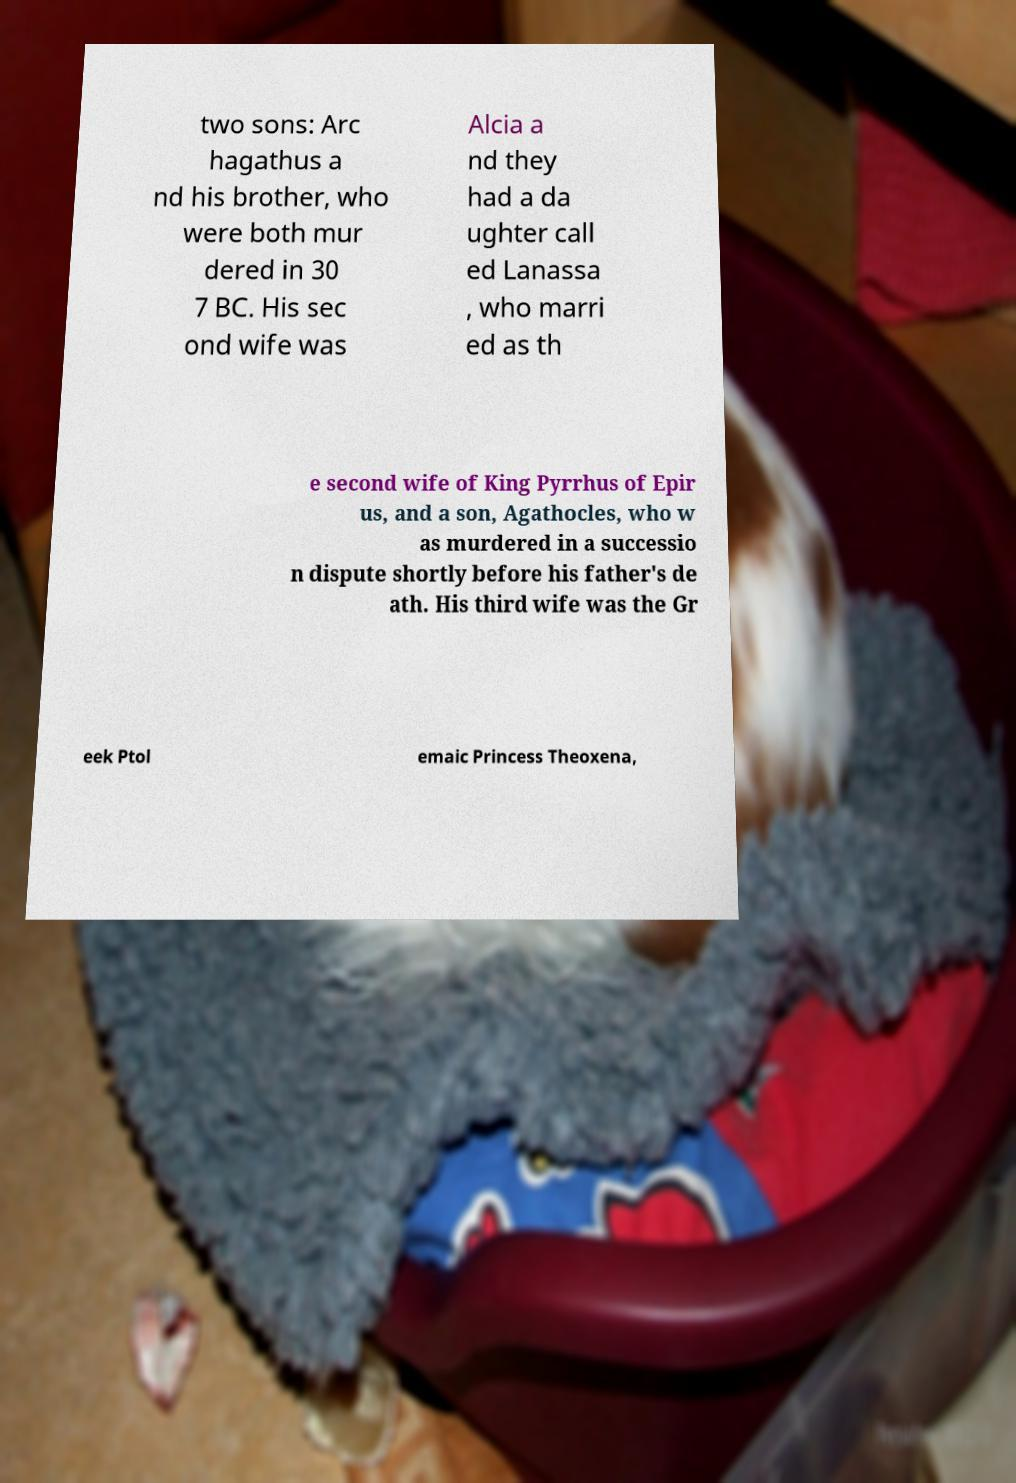Please read and relay the text visible in this image. What does it say? two sons: Arc hagathus a nd his brother, who were both mur dered in 30 7 BC. His sec ond wife was Alcia a nd they had a da ughter call ed Lanassa , who marri ed as th e second wife of King Pyrrhus of Epir us, and a son, Agathocles, who w as murdered in a successio n dispute shortly before his father's de ath. His third wife was the Gr eek Ptol emaic Princess Theoxena, 